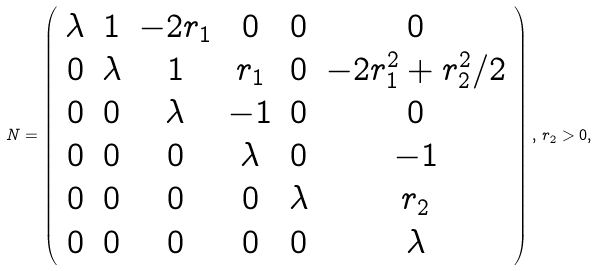Convert formula to latex. <formula><loc_0><loc_0><loc_500><loc_500>N = \left ( \begin{array} { c c c c c c } \lambda & 1 & - 2 r _ { 1 } & 0 & 0 & 0 \\ 0 & \lambda & 1 & r _ { 1 } & 0 & - 2 r _ { 1 } ^ { 2 } + r _ { 2 } ^ { 2 } / 2 \\ 0 & 0 & \lambda & - 1 & 0 & 0 \\ 0 & 0 & 0 & \lambda & 0 & - 1 \\ 0 & 0 & 0 & 0 & \lambda & r _ { 2 } \\ 0 & 0 & 0 & 0 & 0 & \lambda \end{array} \right ) , \, r _ { 2 } > 0 ,</formula> 